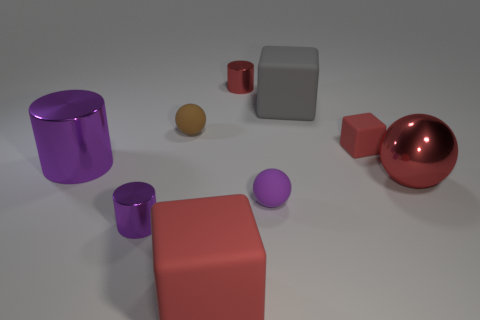Do the rubber sphere on the right side of the brown ball and the rubber block behind the small brown rubber ball have the same size?
Keep it short and to the point. No. Is there a purple cylinder made of the same material as the large red cube?
Offer a very short reply. No. There is another metal cylinder that is the same color as the big cylinder; what is its size?
Provide a succinct answer. Small. Is there a small purple rubber sphere left of the big matte block that is behind the red block behind the small purple cylinder?
Give a very brief answer. Yes. Are there any rubber objects to the right of the tiny red metallic thing?
Give a very brief answer. Yes. How many small brown rubber objects are left of the big thing that is right of the large gray block?
Provide a short and direct response. 1. There is a purple rubber thing; is it the same size as the cylinder that is behind the tiny red matte cube?
Provide a succinct answer. Yes. Is there a tiny metallic thing of the same color as the large metal cylinder?
Ensure brevity in your answer.  Yes. There is a red thing that is made of the same material as the red cylinder; what is its size?
Your answer should be compact. Large. Does the large gray block have the same material as the large cylinder?
Make the answer very short. No. 